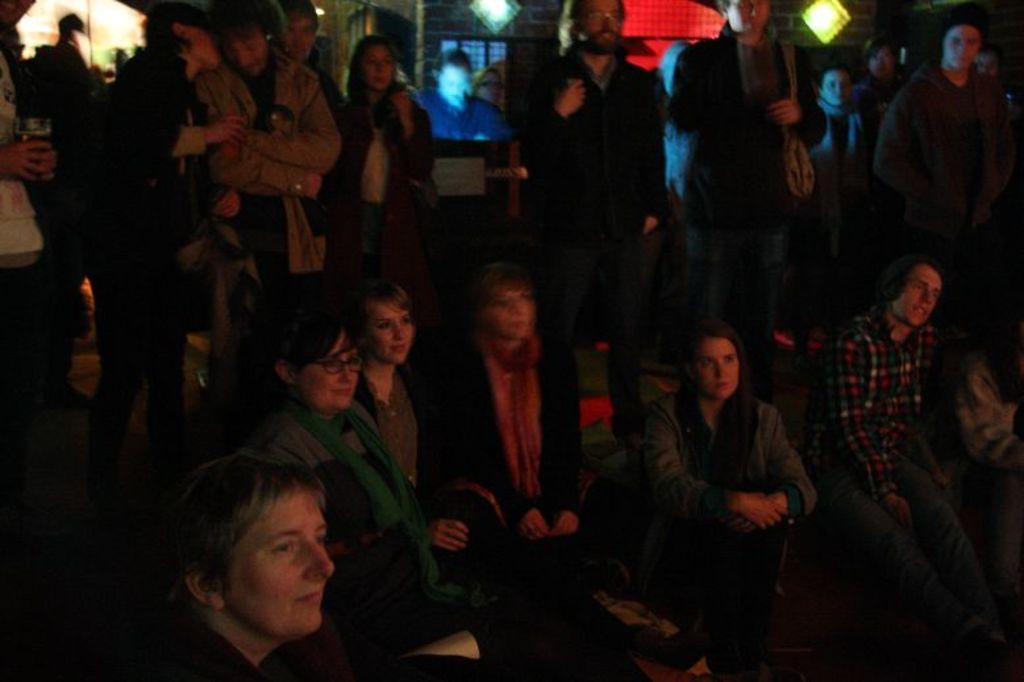What are the people in the image doing? There are people sitting and standing in the image. What can be seen illuminating the area in the image? There are lights visible in the image. What is displayed in the background of the image? There appears to be a screen displaying something in the background. What type of harmony is being played by the system in the image? There is no mention of harmony or a system in the image; it features people sitting and standing with lights and a screen in the background. 